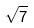<formula> <loc_0><loc_0><loc_500><loc_500>\sqrt { 7 }</formula> 